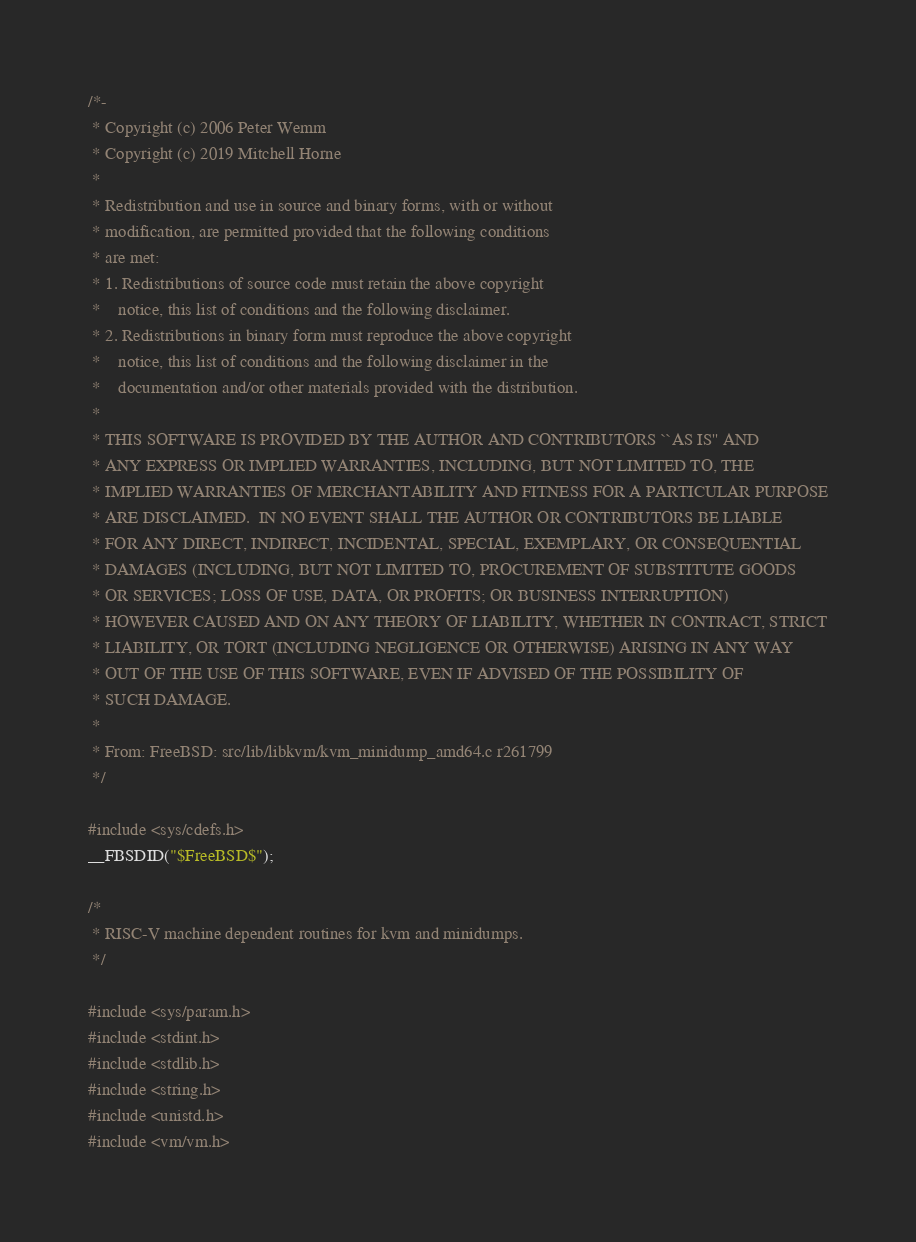<code> <loc_0><loc_0><loc_500><loc_500><_C_>/*-
 * Copyright (c) 2006 Peter Wemm
 * Copyright (c) 2019 Mitchell Horne
 *
 * Redistribution and use in source and binary forms, with or without
 * modification, are permitted provided that the following conditions
 * are met:
 * 1. Redistributions of source code must retain the above copyright
 *    notice, this list of conditions and the following disclaimer.
 * 2. Redistributions in binary form must reproduce the above copyright
 *    notice, this list of conditions and the following disclaimer in the
 *    documentation and/or other materials provided with the distribution.
 *
 * THIS SOFTWARE IS PROVIDED BY THE AUTHOR AND CONTRIBUTORS ``AS IS'' AND
 * ANY EXPRESS OR IMPLIED WARRANTIES, INCLUDING, BUT NOT LIMITED TO, THE
 * IMPLIED WARRANTIES OF MERCHANTABILITY AND FITNESS FOR A PARTICULAR PURPOSE
 * ARE DISCLAIMED.  IN NO EVENT SHALL THE AUTHOR OR CONTRIBUTORS BE LIABLE
 * FOR ANY DIRECT, INDIRECT, INCIDENTAL, SPECIAL, EXEMPLARY, OR CONSEQUENTIAL
 * DAMAGES (INCLUDING, BUT NOT LIMITED TO, PROCUREMENT OF SUBSTITUTE GOODS
 * OR SERVICES; LOSS OF USE, DATA, OR PROFITS; OR BUSINESS INTERRUPTION)
 * HOWEVER CAUSED AND ON ANY THEORY OF LIABILITY, WHETHER IN CONTRACT, STRICT
 * LIABILITY, OR TORT (INCLUDING NEGLIGENCE OR OTHERWISE) ARISING IN ANY WAY
 * OUT OF THE USE OF THIS SOFTWARE, EVEN IF ADVISED OF THE POSSIBILITY OF
 * SUCH DAMAGE.
 *
 * From: FreeBSD: src/lib/libkvm/kvm_minidump_amd64.c r261799
 */

#include <sys/cdefs.h>
__FBSDID("$FreeBSD$");

/*
 * RISC-V machine dependent routines for kvm and minidumps.
 */

#include <sys/param.h>
#include <stdint.h>
#include <stdlib.h>
#include <string.h>
#include <unistd.h>
#include <vm/vm.h></code> 